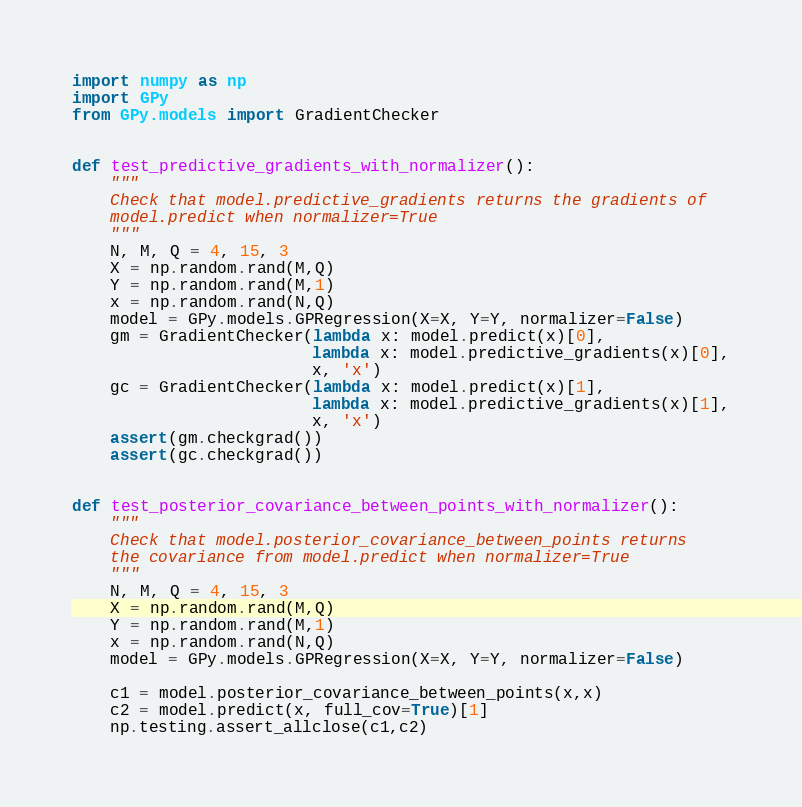Convert code to text. <code><loc_0><loc_0><loc_500><loc_500><_Python_>import numpy as np
import GPy
from GPy.models import GradientChecker


def test_predictive_gradients_with_normalizer():
    """
    Check that model.predictive_gradients returns the gradients of
    model.predict when normalizer=True 
    """
    N, M, Q = 4, 15, 3
    X = np.random.rand(M,Q)
    Y = np.random.rand(M,1)
    x = np.random.rand(N,Q)
    model = GPy.models.GPRegression(X=X, Y=Y, normalizer=False)
    gm = GradientChecker(lambda x: model.predict(x)[0],
                         lambda x: model.predictive_gradients(x)[0],
                         x, 'x')
    gc = GradientChecker(lambda x: model.predict(x)[1],
                         lambda x: model.predictive_gradients(x)[1],
                         x, 'x')
    assert(gm.checkgrad())
    assert(gc.checkgrad())


def test_posterior_covariance_between_points_with_normalizer():
    """
    Check that model.posterior_covariance_between_points returns 
    the covariance from model.predict when normalizer=True
    """
    N, M, Q = 4, 15, 3
    X = np.random.rand(M,Q)
    Y = np.random.rand(M,1)
    x = np.random.rand(N,Q)
    model = GPy.models.GPRegression(X=X, Y=Y, normalizer=False)

    c1 = model.posterior_covariance_between_points(x,x)
    c2 = model.predict(x, full_cov=True)[1]
    np.testing.assert_allclose(c1,c2)


</code> 